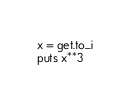Convert code to text. <code><loc_0><loc_0><loc_500><loc_500><_Ruby_>x = get.to_i
puts x**3
</code> 